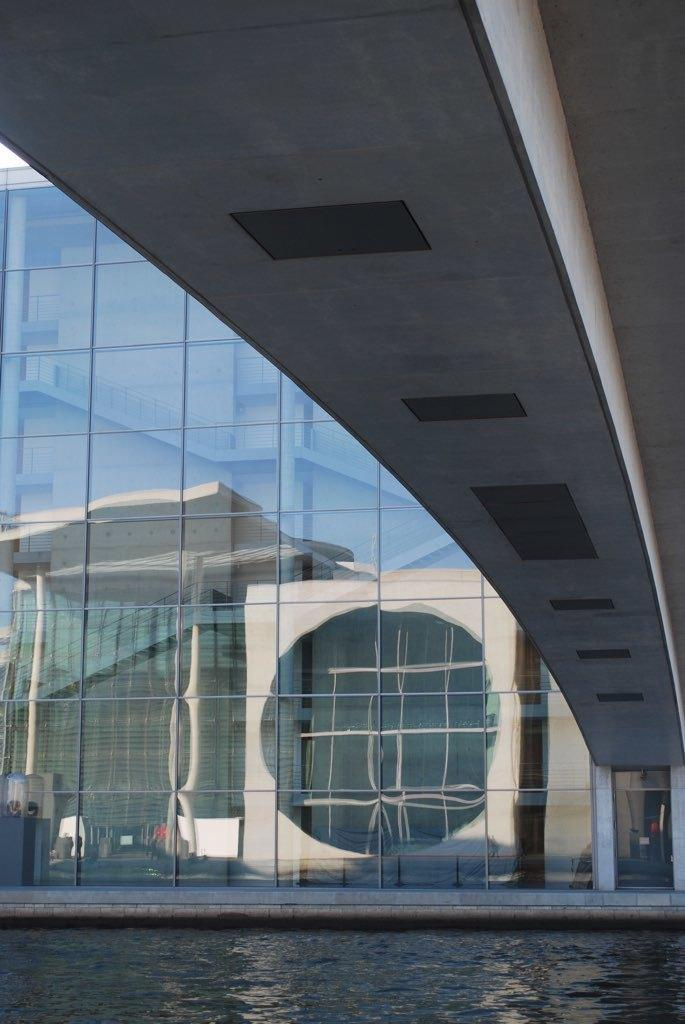What type of structure is present in the image? There is a building in the image. What material is the building made of? The building is made up of glass. What else can be seen in the image besides the building? There is water visible in the image. How does the representative from the pollution control agency feel about the water in the image? There is no representative from the pollution control agency present in the image, and therefore their feelings cannot be determined. 